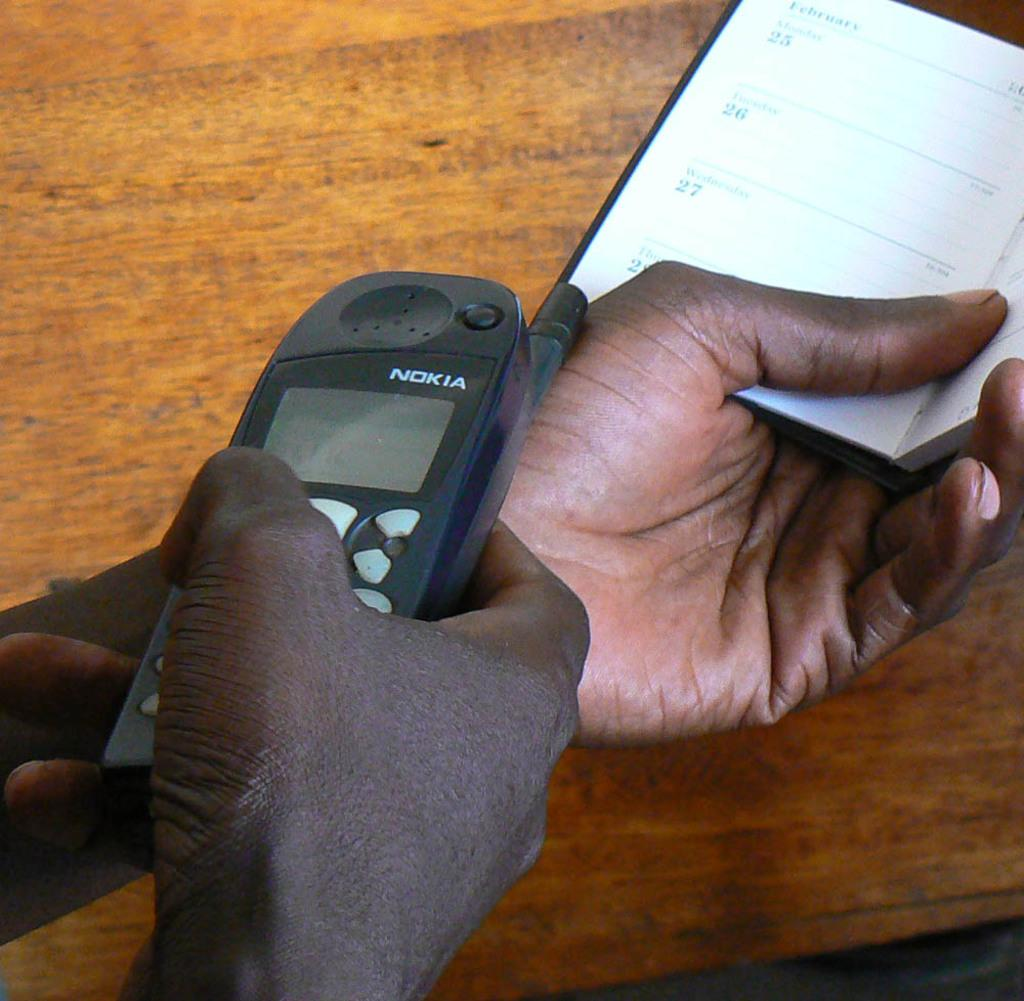<image>
Relay a brief, clear account of the picture shown. A man holds a nokia cell phone while looking through a calendar. 